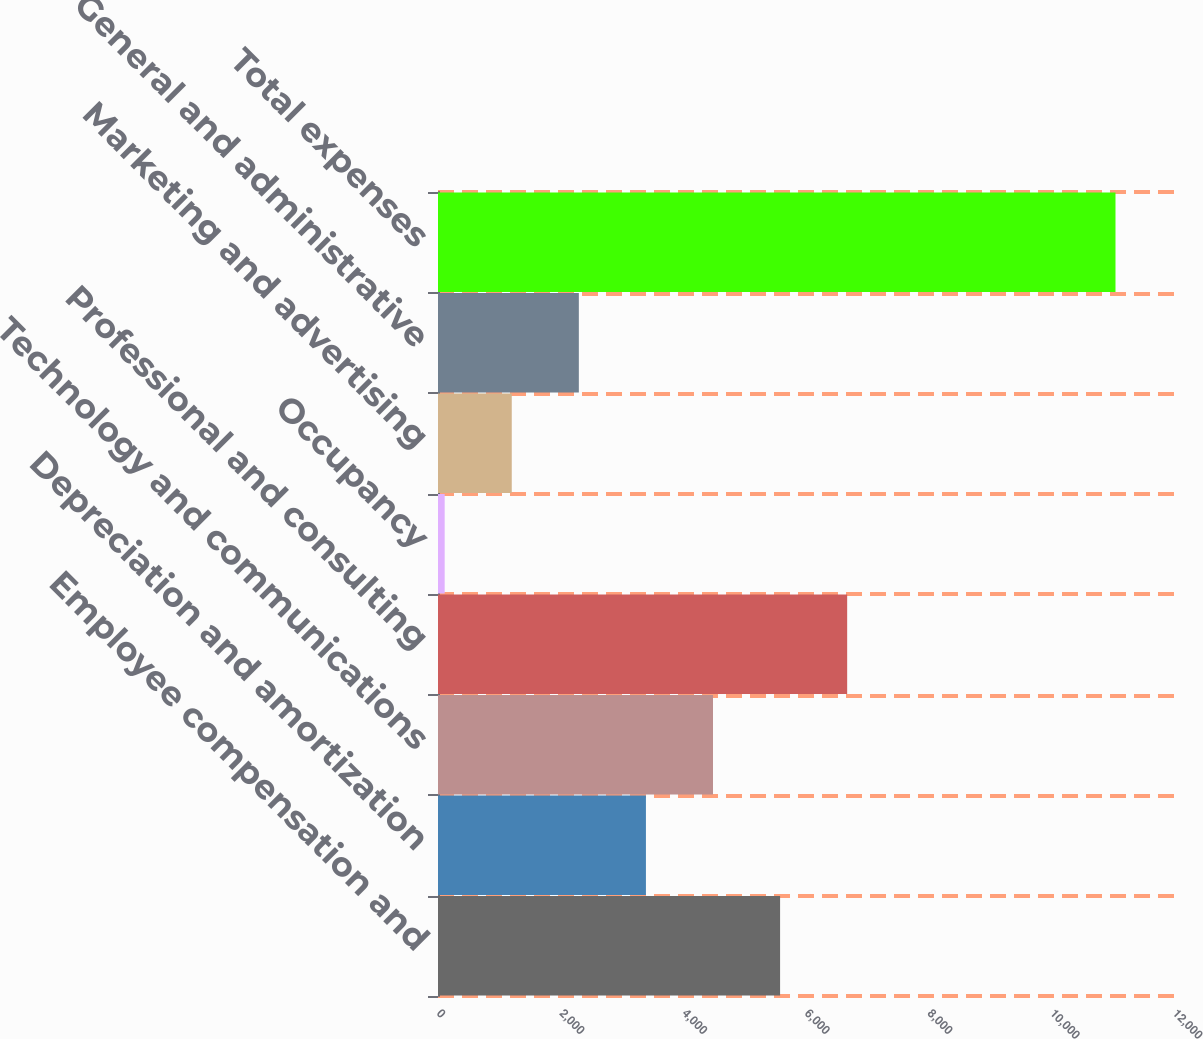<chart> <loc_0><loc_0><loc_500><loc_500><bar_chart><fcel>Employee compensation and<fcel>Depreciation and amortization<fcel>Technology and communications<fcel>Professional and consulting<fcel>Occupancy<fcel>Marketing and advertising<fcel>General and administrative<fcel>Total expenses<nl><fcel>5577.5<fcel>3390.1<fcel>4483.8<fcel>6671.2<fcel>109<fcel>1202.7<fcel>2296.4<fcel>11046<nl></chart> 